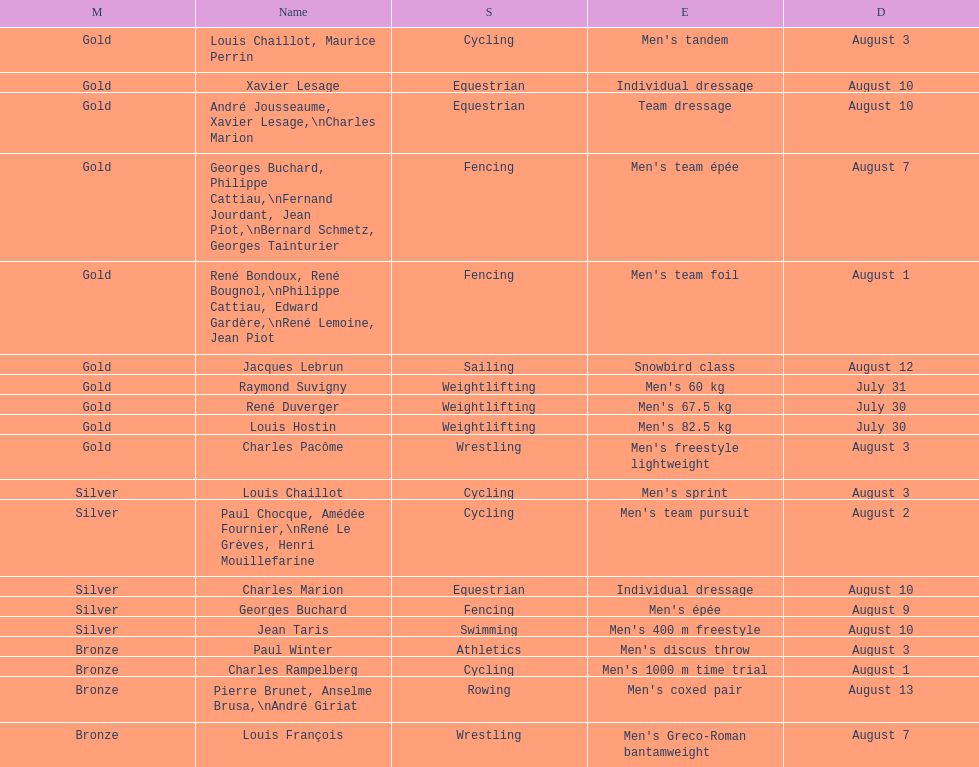Louis chaillot won a gold medal for cycling and a silver medal for what sport? Cycling. 